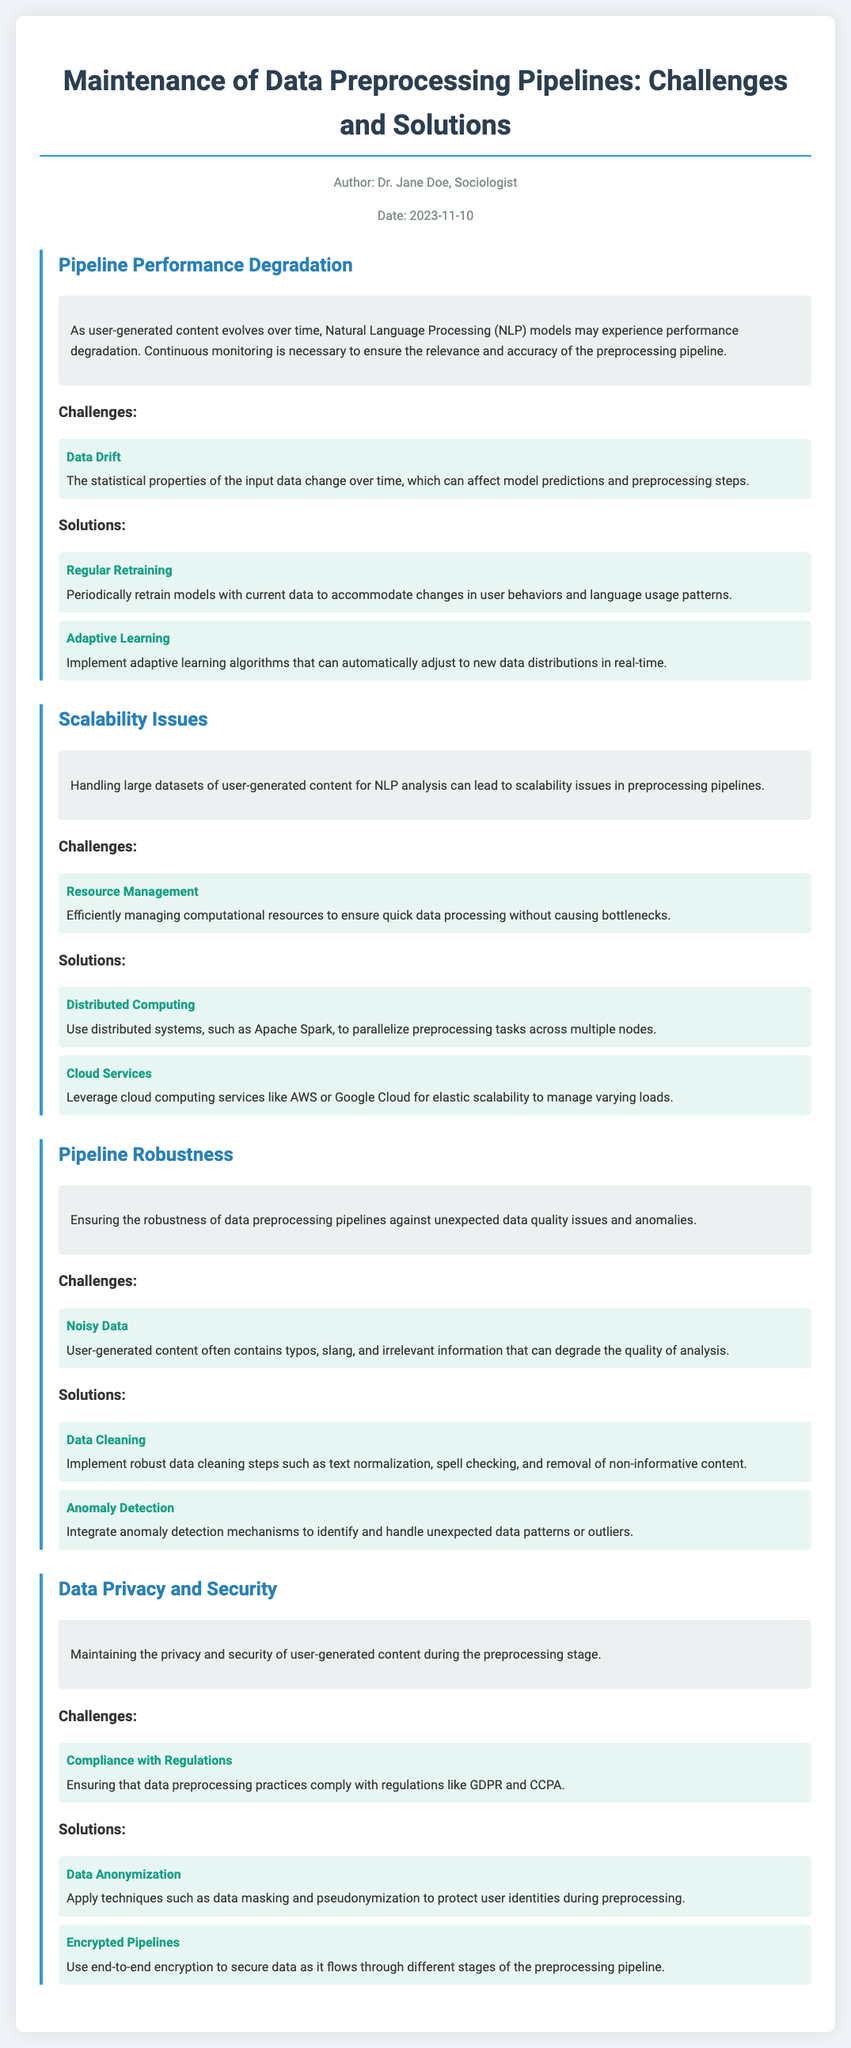What is the title of the document? The title, as presented in the document header, summarizes the content and focus of the maintenance log.
Answer: Maintenance of Data Preprocessing Pipelines: Challenges and Solutions Who is the author of the document? The author is mentioned in the metadata section, which provides information about the document's authorship.
Answer: Dr. Jane Doe What is the date of the document? The date is included in the metadata section, providing context about when the document was created or last updated.
Answer: 2023-11-10 What is one challenge related to data drift? The document highlights specific challenges associated with data drift under the Pipeline Performance Degradation section.
Answer: The statistical properties of the input data change over time What is a solution for pipeline performance degradation? The document outlines effective solutions for each identified challenge within the respective sections.
Answer: Regular Retraining What technology is suggested for distributed computing? The solutions section mentions specific technologies that can address scalability issues in processing pipelines.
Answer: Apache Spark What is a data privacy challenge mentioned? The challenges associated with data privacy and security are discussed in their respective section of the document.
Answer: Compliance with Regulations What is a method of data anonymization described? The document lists techniques used to protect user identities during the preprocessing stage in the data privacy and security section.
Answer: Data masking What type of data issue does the document recognize under Pipeline Robustness? This issue is highlighted as a challenge affecting the quality of analysis in the preprocessing pipelines.
Answer: Noisy Data What does "Encrypted Pipelines" refer to? This term refers to a solution designed to enhance security during data processing and is mentioned in the data privacy solutions section.
Answer: Use end-to-end encryption 